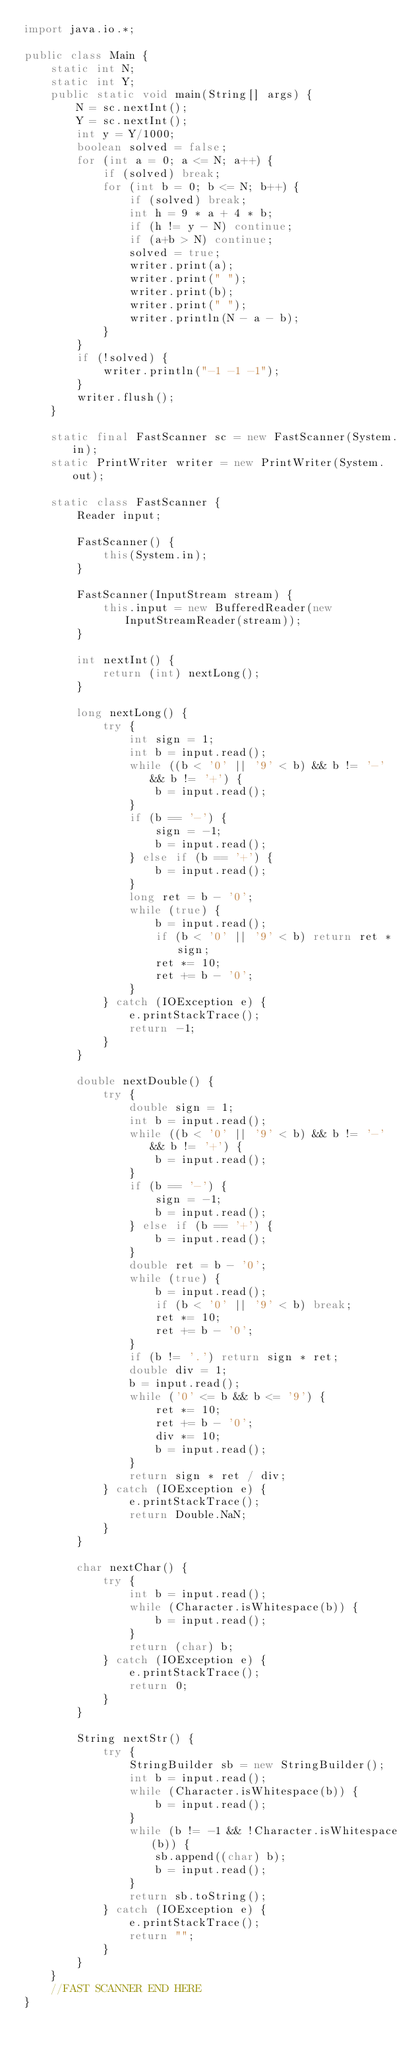Convert code to text. <code><loc_0><loc_0><loc_500><loc_500><_Java_>import java.io.*;

public class Main {
    static int N;
    static int Y;
    public static void main(String[] args) {
        N = sc.nextInt();
        Y = sc.nextInt();
        int y = Y/1000;
        boolean solved = false;
        for (int a = 0; a <= N; a++) {
            if (solved) break;
            for (int b = 0; b <= N; b++) {
                if (solved) break;
                int h = 9 * a + 4 * b;
                if (h != y - N) continue;
                if (a+b > N) continue;
                solved = true;
                writer.print(a);
                writer.print(" ");
                writer.print(b);
                writer.print(" ");
                writer.println(N - a - b);
            }
        }
        if (!solved) {
            writer.println("-1 -1 -1");
        }
        writer.flush();
    }

    static final FastScanner sc = new FastScanner(System.in);
    static PrintWriter writer = new PrintWriter(System.out);

    static class FastScanner {
        Reader input;
 
        FastScanner() {
            this(System.in);
        }
 
        FastScanner(InputStream stream) {
            this.input = new BufferedReader(new InputStreamReader(stream));
        }
 
        int nextInt() {
            return (int) nextLong();
        }
 
        long nextLong() {
            try {
                int sign = 1;
                int b = input.read();
                while ((b < '0' || '9' < b) && b != '-' && b != '+') {
                    b = input.read();
                }
                if (b == '-') {
                    sign = -1;
                    b = input.read();
                } else if (b == '+') {
                    b = input.read();
                }
                long ret = b - '0';
                while (true) {
                    b = input.read();
                    if (b < '0' || '9' < b) return ret * sign;
                    ret *= 10;
                    ret += b - '0';
                }
            } catch (IOException e) {
                e.printStackTrace();
                return -1;
            }
        }
 
        double nextDouble() {
            try {
                double sign = 1;
                int b = input.read();
                while ((b < '0' || '9' < b) && b != '-' && b != '+') {
                    b = input.read();
                }
                if (b == '-') {
                    sign = -1;
                    b = input.read();
                } else if (b == '+') {
                    b = input.read();
                }
                double ret = b - '0';
                while (true) {
                    b = input.read();
                    if (b < '0' || '9' < b) break;
                    ret *= 10;
                    ret += b - '0';
                }
                if (b != '.') return sign * ret;
                double div = 1;
                b = input.read();
                while ('0' <= b && b <= '9') {
                    ret *= 10;
                    ret += b - '0';
                    div *= 10;
                    b = input.read();
                }
                return sign * ret / div;
            } catch (IOException e) {
                e.printStackTrace();
                return Double.NaN;
            }
        }
 
        char nextChar() {
            try {
                int b = input.read();
                while (Character.isWhitespace(b)) {
                    b = input.read();
                }
                return (char) b;
            } catch (IOException e) {
                e.printStackTrace();
                return 0;
            }
        }
 
        String nextStr() {
            try {
                StringBuilder sb = new StringBuilder();
                int b = input.read();
                while (Character.isWhitespace(b)) {
                    b = input.read();
                }
                while (b != -1 && !Character.isWhitespace(b)) {
                    sb.append((char) b);
                    b = input.read();
                }
                return sb.toString();
            } catch (IOException e) {
                e.printStackTrace();
                return "";
            }
        }
    }
    //FAST SCANNER END HERE
}
</code> 